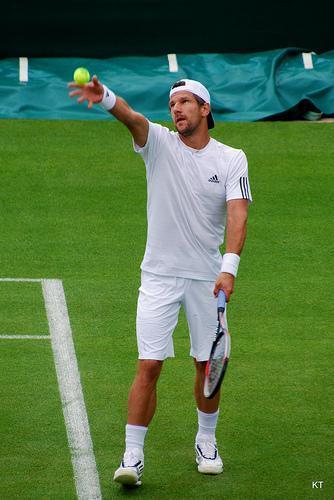How many people are there?
Give a very brief answer. 1. 